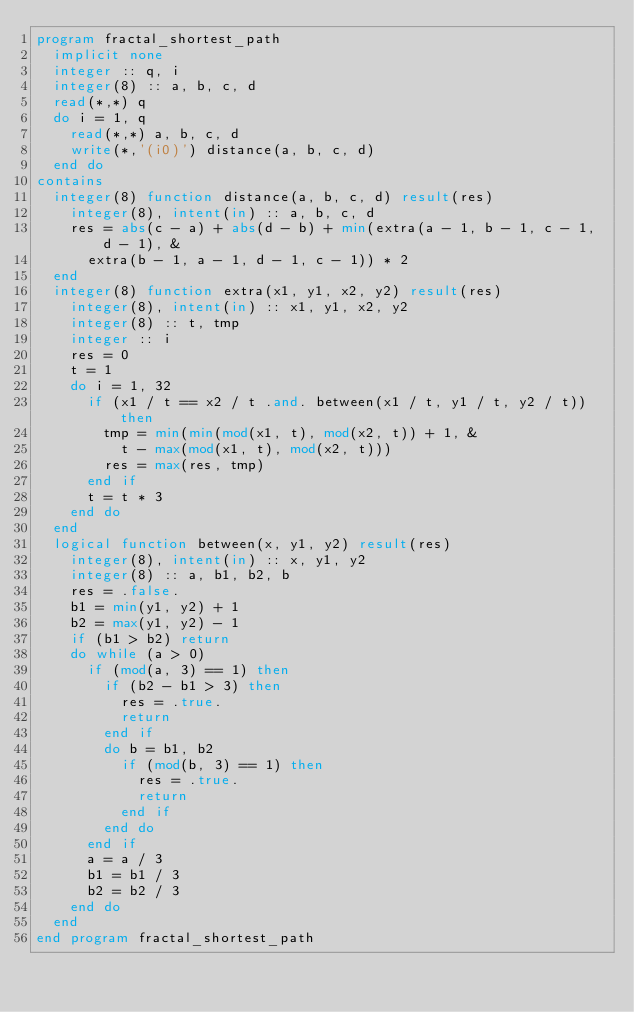Convert code to text. <code><loc_0><loc_0><loc_500><loc_500><_FORTRAN_>program fractal_shortest_path
  implicit none
  integer :: q, i
  integer(8) :: a, b, c, d
  read(*,*) q
  do i = 1, q
    read(*,*) a, b, c, d
    write(*,'(i0)') distance(a, b, c, d)
  end do
contains
  integer(8) function distance(a, b, c, d) result(res)
    integer(8), intent(in) :: a, b, c, d
    res = abs(c - a) + abs(d - b) + min(extra(a - 1, b - 1, c - 1, d - 1), &
      extra(b - 1, a - 1, d - 1, c - 1)) * 2
  end
  integer(8) function extra(x1, y1, x2, y2) result(res)
    integer(8), intent(in) :: x1, y1, x2, y2
    integer(8) :: t, tmp
    integer :: i
    res = 0
    t = 1
    do i = 1, 32
      if (x1 / t == x2 / t .and. between(x1 / t, y1 / t, y2 / t)) then
        tmp = min(min(mod(x1, t), mod(x2, t)) + 1, &
          t - max(mod(x1, t), mod(x2, t)))
        res = max(res, tmp)
      end if
      t = t * 3
    end do
  end
  logical function between(x, y1, y2) result(res)
    integer(8), intent(in) :: x, y1, y2
    integer(8) :: a, b1, b2, b
    res = .false.
    b1 = min(y1, y2) + 1
    b2 = max(y1, y2) - 1
    if (b1 > b2) return
    do while (a > 0)
      if (mod(a, 3) == 1) then
        if (b2 - b1 > 3) then
          res = .true.
          return
        end if
        do b = b1, b2
          if (mod(b, 3) == 1) then
            res = .true.
            return
          end if
        end do
      end if
      a = a / 3
      b1 = b1 / 3
      b2 = b2 / 3
    end do
  end
end program fractal_shortest_path</code> 